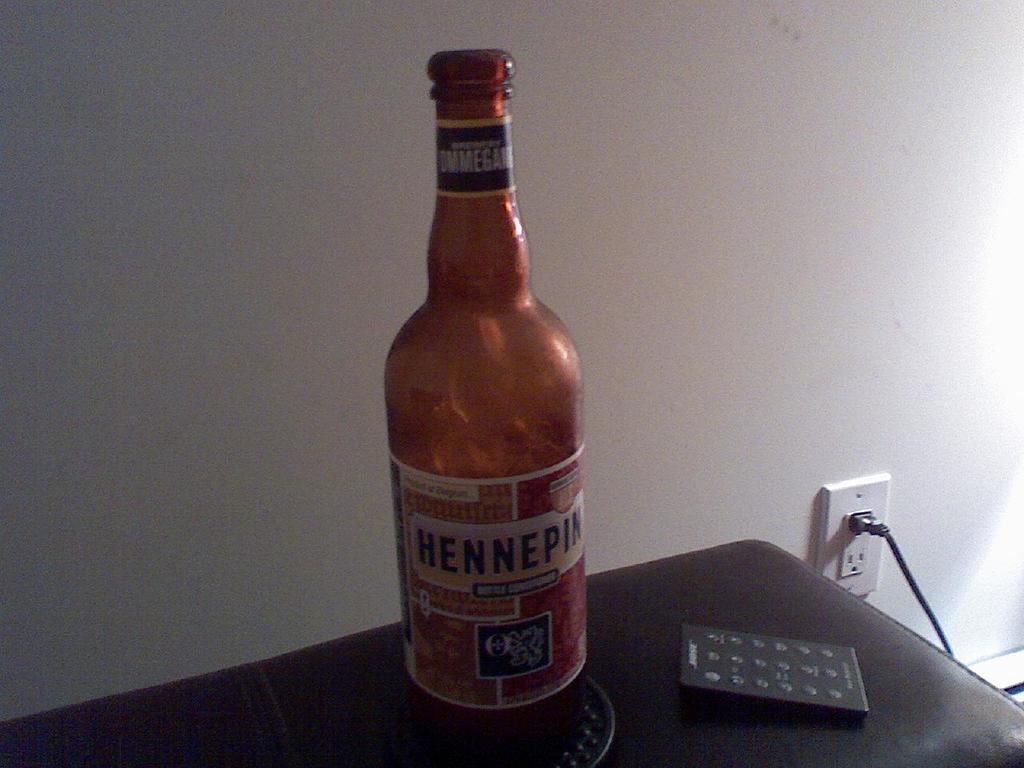What are the last three letters of the brand name?
Ensure brevity in your answer.  Pin. 